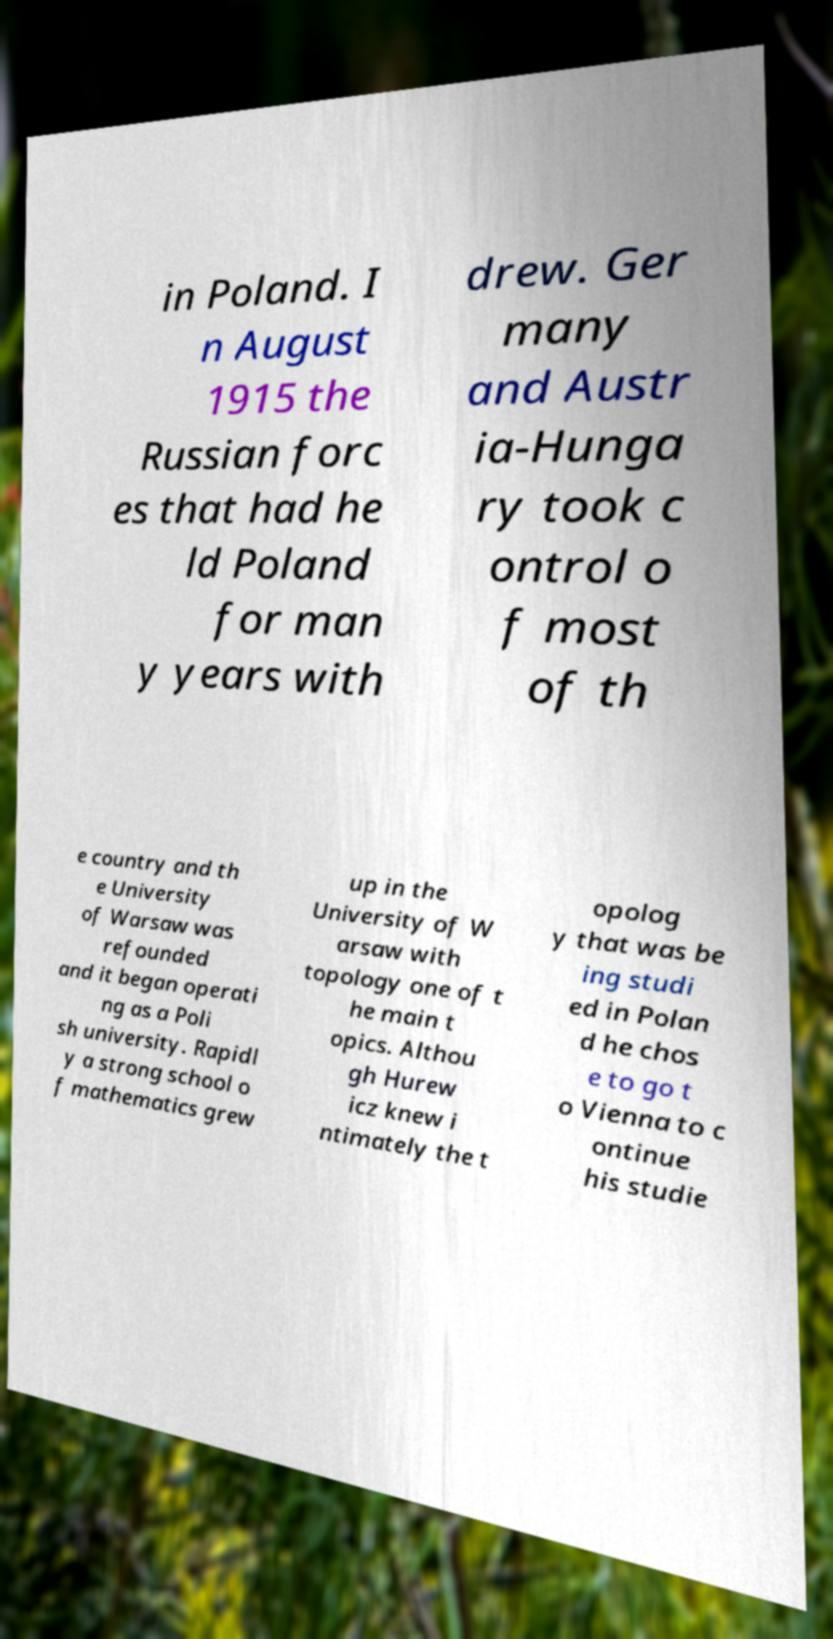Please identify and transcribe the text found in this image. in Poland. I n August 1915 the Russian forc es that had he ld Poland for man y years with drew. Ger many and Austr ia-Hunga ry took c ontrol o f most of th e country and th e University of Warsaw was refounded and it began operati ng as a Poli sh university. Rapidl y a strong school o f mathematics grew up in the University of W arsaw with topology one of t he main t opics. Althou gh Hurew icz knew i ntimately the t opolog y that was be ing studi ed in Polan d he chos e to go t o Vienna to c ontinue his studie 